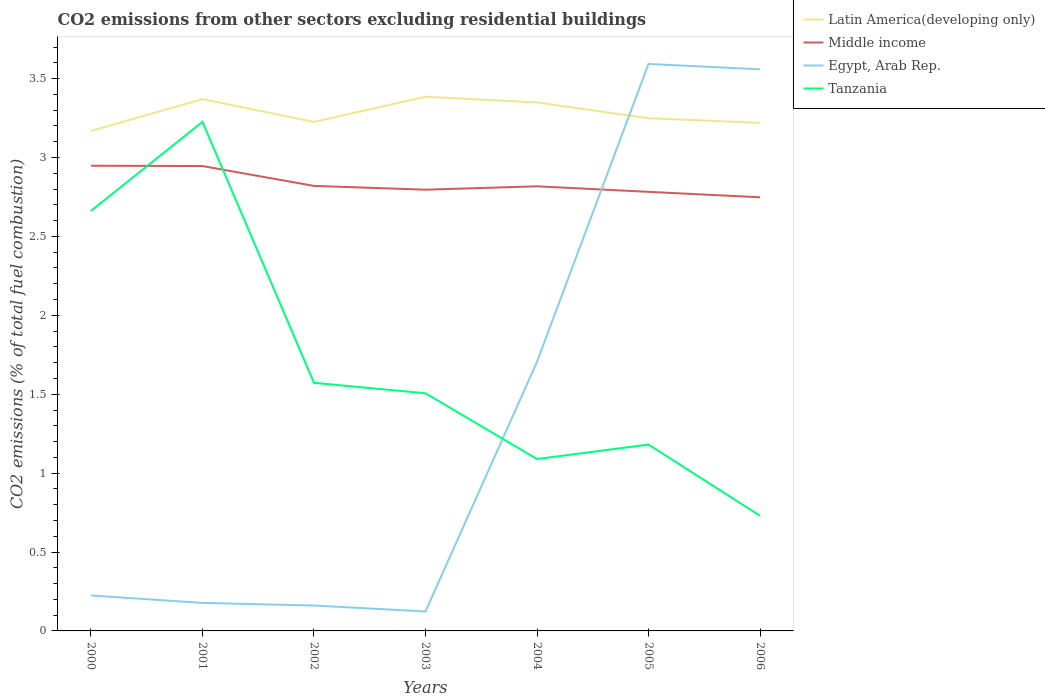How many different coloured lines are there?
Offer a very short reply. 4. Does the line corresponding to Egypt, Arab Rep. intersect with the line corresponding to Latin America(developing only)?
Offer a terse response. Yes. Is the number of lines equal to the number of legend labels?
Offer a very short reply. Yes. Across all years, what is the maximum total CO2 emitted in Egypt, Arab Rep.?
Your response must be concise. 0.12. In which year was the total CO2 emitted in Tanzania maximum?
Ensure brevity in your answer.  2006. What is the total total CO2 emitted in Tanzania in the graph?
Provide a short and direct response. 2.04. What is the difference between the highest and the second highest total CO2 emitted in Egypt, Arab Rep.?
Your answer should be very brief. 3.47. What is the difference between the highest and the lowest total CO2 emitted in Latin America(developing only)?
Keep it short and to the point. 3. Is the total CO2 emitted in Latin America(developing only) strictly greater than the total CO2 emitted in Middle income over the years?
Your answer should be compact. No. How many years are there in the graph?
Offer a very short reply. 7. Does the graph contain any zero values?
Make the answer very short. No. How many legend labels are there?
Provide a succinct answer. 4. What is the title of the graph?
Make the answer very short. CO2 emissions from other sectors excluding residential buildings. What is the label or title of the Y-axis?
Ensure brevity in your answer.  CO2 emissions (% of total fuel combustion). What is the CO2 emissions (% of total fuel combustion) of Latin America(developing only) in 2000?
Offer a very short reply. 3.17. What is the CO2 emissions (% of total fuel combustion) in Middle income in 2000?
Your answer should be very brief. 2.95. What is the CO2 emissions (% of total fuel combustion) in Egypt, Arab Rep. in 2000?
Your answer should be very brief. 0.22. What is the CO2 emissions (% of total fuel combustion) in Tanzania in 2000?
Your response must be concise. 2.66. What is the CO2 emissions (% of total fuel combustion) of Latin America(developing only) in 2001?
Keep it short and to the point. 3.37. What is the CO2 emissions (% of total fuel combustion) of Middle income in 2001?
Your answer should be compact. 2.95. What is the CO2 emissions (% of total fuel combustion) of Egypt, Arab Rep. in 2001?
Your response must be concise. 0.18. What is the CO2 emissions (% of total fuel combustion) in Tanzania in 2001?
Provide a succinct answer. 3.23. What is the CO2 emissions (% of total fuel combustion) of Latin America(developing only) in 2002?
Keep it short and to the point. 3.23. What is the CO2 emissions (% of total fuel combustion) of Middle income in 2002?
Your answer should be very brief. 2.82. What is the CO2 emissions (% of total fuel combustion) in Egypt, Arab Rep. in 2002?
Offer a terse response. 0.16. What is the CO2 emissions (% of total fuel combustion) in Tanzania in 2002?
Your answer should be compact. 1.57. What is the CO2 emissions (% of total fuel combustion) of Latin America(developing only) in 2003?
Your response must be concise. 3.39. What is the CO2 emissions (% of total fuel combustion) in Middle income in 2003?
Make the answer very short. 2.8. What is the CO2 emissions (% of total fuel combustion) of Egypt, Arab Rep. in 2003?
Offer a very short reply. 0.12. What is the CO2 emissions (% of total fuel combustion) of Tanzania in 2003?
Offer a terse response. 1.51. What is the CO2 emissions (% of total fuel combustion) of Latin America(developing only) in 2004?
Your answer should be very brief. 3.35. What is the CO2 emissions (% of total fuel combustion) in Middle income in 2004?
Your response must be concise. 2.82. What is the CO2 emissions (% of total fuel combustion) in Egypt, Arab Rep. in 2004?
Make the answer very short. 1.71. What is the CO2 emissions (% of total fuel combustion) in Tanzania in 2004?
Offer a terse response. 1.09. What is the CO2 emissions (% of total fuel combustion) of Latin America(developing only) in 2005?
Offer a very short reply. 3.25. What is the CO2 emissions (% of total fuel combustion) of Middle income in 2005?
Provide a short and direct response. 2.78. What is the CO2 emissions (% of total fuel combustion) in Egypt, Arab Rep. in 2005?
Provide a succinct answer. 3.59. What is the CO2 emissions (% of total fuel combustion) of Tanzania in 2005?
Your response must be concise. 1.18. What is the CO2 emissions (% of total fuel combustion) of Latin America(developing only) in 2006?
Give a very brief answer. 3.22. What is the CO2 emissions (% of total fuel combustion) in Middle income in 2006?
Your answer should be very brief. 2.75. What is the CO2 emissions (% of total fuel combustion) in Egypt, Arab Rep. in 2006?
Offer a terse response. 3.56. What is the CO2 emissions (% of total fuel combustion) of Tanzania in 2006?
Your answer should be compact. 0.73. Across all years, what is the maximum CO2 emissions (% of total fuel combustion) of Latin America(developing only)?
Provide a succinct answer. 3.39. Across all years, what is the maximum CO2 emissions (% of total fuel combustion) in Middle income?
Offer a terse response. 2.95. Across all years, what is the maximum CO2 emissions (% of total fuel combustion) in Egypt, Arab Rep.?
Keep it short and to the point. 3.59. Across all years, what is the maximum CO2 emissions (% of total fuel combustion) of Tanzania?
Provide a succinct answer. 3.23. Across all years, what is the minimum CO2 emissions (% of total fuel combustion) in Latin America(developing only)?
Provide a succinct answer. 3.17. Across all years, what is the minimum CO2 emissions (% of total fuel combustion) of Middle income?
Your answer should be very brief. 2.75. Across all years, what is the minimum CO2 emissions (% of total fuel combustion) in Egypt, Arab Rep.?
Provide a short and direct response. 0.12. Across all years, what is the minimum CO2 emissions (% of total fuel combustion) in Tanzania?
Provide a short and direct response. 0.73. What is the total CO2 emissions (% of total fuel combustion) in Latin America(developing only) in the graph?
Keep it short and to the point. 22.97. What is the total CO2 emissions (% of total fuel combustion) of Middle income in the graph?
Your answer should be very brief. 19.86. What is the total CO2 emissions (% of total fuel combustion) of Egypt, Arab Rep. in the graph?
Make the answer very short. 9.54. What is the total CO2 emissions (% of total fuel combustion) of Tanzania in the graph?
Keep it short and to the point. 11.97. What is the difference between the CO2 emissions (% of total fuel combustion) in Latin America(developing only) in 2000 and that in 2001?
Your answer should be compact. -0.2. What is the difference between the CO2 emissions (% of total fuel combustion) in Middle income in 2000 and that in 2001?
Offer a terse response. 0. What is the difference between the CO2 emissions (% of total fuel combustion) in Egypt, Arab Rep. in 2000 and that in 2001?
Your answer should be compact. 0.05. What is the difference between the CO2 emissions (% of total fuel combustion) of Tanzania in 2000 and that in 2001?
Provide a succinct answer. -0.56. What is the difference between the CO2 emissions (% of total fuel combustion) of Latin America(developing only) in 2000 and that in 2002?
Provide a short and direct response. -0.06. What is the difference between the CO2 emissions (% of total fuel combustion) in Middle income in 2000 and that in 2002?
Provide a succinct answer. 0.13. What is the difference between the CO2 emissions (% of total fuel combustion) in Egypt, Arab Rep. in 2000 and that in 2002?
Keep it short and to the point. 0.06. What is the difference between the CO2 emissions (% of total fuel combustion) in Tanzania in 2000 and that in 2002?
Your answer should be very brief. 1.09. What is the difference between the CO2 emissions (% of total fuel combustion) in Latin America(developing only) in 2000 and that in 2003?
Provide a short and direct response. -0.22. What is the difference between the CO2 emissions (% of total fuel combustion) of Middle income in 2000 and that in 2003?
Provide a succinct answer. 0.15. What is the difference between the CO2 emissions (% of total fuel combustion) of Egypt, Arab Rep. in 2000 and that in 2003?
Keep it short and to the point. 0.1. What is the difference between the CO2 emissions (% of total fuel combustion) of Tanzania in 2000 and that in 2003?
Your response must be concise. 1.16. What is the difference between the CO2 emissions (% of total fuel combustion) of Latin America(developing only) in 2000 and that in 2004?
Make the answer very short. -0.18. What is the difference between the CO2 emissions (% of total fuel combustion) of Middle income in 2000 and that in 2004?
Offer a terse response. 0.13. What is the difference between the CO2 emissions (% of total fuel combustion) in Egypt, Arab Rep. in 2000 and that in 2004?
Your answer should be compact. -1.48. What is the difference between the CO2 emissions (% of total fuel combustion) of Tanzania in 2000 and that in 2004?
Provide a succinct answer. 1.57. What is the difference between the CO2 emissions (% of total fuel combustion) of Latin America(developing only) in 2000 and that in 2005?
Your response must be concise. -0.08. What is the difference between the CO2 emissions (% of total fuel combustion) of Middle income in 2000 and that in 2005?
Provide a succinct answer. 0.17. What is the difference between the CO2 emissions (% of total fuel combustion) of Egypt, Arab Rep. in 2000 and that in 2005?
Provide a short and direct response. -3.37. What is the difference between the CO2 emissions (% of total fuel combustion) of Tanzania in 2000 and that in 2005?
Offer a terse response. 1.48. What is the difference between the CO2 emissions (% of total fuel combustion) in Latin America(developing only) in 2000 and that in 2006?
Keep it short and to the point. -0.05. What is the difference between the CO2 emissions (% of total fuel combustion) of Egypt, Arab Rep. in 2000 and that in 2006?
Provide a short and direct response. -3.33. What is the difference between the CO2 emissions (% of total fuel combustion) of Tanzania in 2000 and that in 2006?
Provide a short and direct response. 1.93. What is the difference between the CO2 emissions (% of total fuel combustion) of Latin America(developing only) in 2001 and that in 2002?
Your answer should be very brief. 0.14. What is the difference between the CO2 emissions (% of total fuel combustion) in Middle income in 2001 and that in 2002?
Provide a short and direct response. 0.13. What is the difference between the CO2 emissions (% of total fuel combustion) in Egypt, Arab Rep. in 2001 and that in 2002?
Ensure brevity in your answer.  0.02. What is the difference between the CO2 emissions (% of total fuel combustion) in Tanzania in 2001 and that in 2002?
Offer a terse response. 1.65. What is the difference between the CO2 emissions (% of total fuel combustion) of Latin America(developing only) in 2001 and that in 2003?
Provide a succinct answer. -0.02. What is the difference between the CO2 emissions (% of total fuel combustion) of Middle income in 2001 and that in 2003?
Make the answer very short. 0.15. What is the difference between the CO2 emissions (% of total fuel combustion) in Egypt, Arab Rep. in 2001 and that in 2003?
Offer a very short reply. 0.05. What is the difference between the CO2 emissions (% of total fuel combustion) of Tanzania in 2001 and that in 2003?
Ensure brevity in your answer.  1.72. What is the difference between the CO2 emissions (% of total fuel combustion) in Latin America(developing only) in 2001 and that in 2004?
Keep it short and to the point. 0.02. What is the difference between the CO2 emissions (% of total fuel combustion) of Middle income in 2001 and that in 2004?
Provide a succinct answer. 0.13. What is the difference between the CO2 emissions (% of total fuel combustion) in Egypt, Arab Rep. in 2001 and that in 2004?
Provide a short and direct response. -1.53. What is the difference between the CO2 emissions (% of total fuel combustion) of Tanzania in 2001 and that in 2004?
Your answer should be compact. 2.14. What is the difference between the CO2 emissions (% of total fuel combustion) in Latin America(developing only) in 2001 and that in 2005?
Give a very brief answer. 0.12. What is the difference between the CO2 emissions (% of total fuel combustion) of Middle income in 2001 and that in 2005?
Your response must be concise. 0.16. What is the difference between the CO2 emissions (% of total fuel combustion) of Egypt, Arab Rep. in 2001 and that in 2005?
Provide a short and direct response. -3.42. What is the difference between the CO2 emissions (% of total fuel combustion) of Tanzania in 2001 and that in 2005?
Your answer should be compact. 2.04. What is the difference between the CO2 emissions (% of total fuel combustion) of Latin America(developing only) in 2001 and that in 2006?
Provide a succinct answer. 0.15. What is the difference between the CO2 emissions (% of total fuel combustion) in Middle income in 2001 and that in 2006?
Give a very brief answer. 0.2. What is the difference between the CO2 emissions (% of total fuel combustion) in Egypt, Arab Rep. in 2001 and that in 2006?
Ensure brevity in your answer.  -3.38. What is the difference between the CO2 emissions (% of total fuel combustion) in Tanzania in 2001 and that in 2006?
Make the answer very short. 2.5. What is the difference between the CO2 emissions (% of total fuel combustion) in Latin America(developing only) in 2002 and that in 2003?
Your response must be concise. -0.16. What is the difference between the CO2 emissions (% of total fuel combustion) of Middle income in 2002 and that in 2003?
Provide a succinct answer. 0.02. What is the difference between the CO2 emissions (% of total fuel combustion) of Egypt, Arab Rep. in 2002 and that in 2003?
Provide a succinct answer. 0.04. What is the difference between the CO2 emissions (% of total fuel combustion) of Tanzania in 2002 and that in 2003?
Make the answer very short. 0.07. What is the difference between the CO2 emissions (% of total fuel combustion) in Latin America(developing only) in 2002 and that in 2004?
Keep it short and to the point. -0.12. What is the difference between the CO2 emissions (% of total fuel combustion) in Middle income in 2002 and that in 2004?
Provide a succinct answer. 0. What is the difference between the CO2 emissions (% of total fuel combustion) of Egypt, Arab Rep. in 2002 and that in 2004?
Keep it short and to the point. -1.54. What is the difference between the CO2 emissions (% of total fuel combustion) in Tanzania in 2002 and that in 2004?
Provide a short and direct response. 0.48. What is the difference between the CO2 emissions (% of total fuel combustion) in Latin America(developing only) in 2002 and that in 2005?
Your answer should be compact. -0.02. What is the difference between the CO2 emissions (% of total fuel combustion) of Middle income in 2002 and that in 2005?
Offer a very short reply. 0.04. What is the difference between the CO2 emissions (% of total fuel combustion) in Egypt, Arab Rep. in 2002 and that in 2005?
Ensure brevity in your answer.  -3.43. What is the difference between the CO2 emissions (% of total fuel combustion) of Tanzania in 2002 and that in 2005?
Provide a short and direct response. 0.39. What is the difference between the CO2 emissions (% of total fuel combustion) of Latin America(developing only) in 2002 and that in 2006?
Offer a very short reply. 0.01. What is the difference between the CO2 emissions (% of total fuel combustion) in Middle income in 2002 and that in 2006?
Provide a succinct answer. 0.07. What is the difference between the CO2 emissions (% of total fuel combustion) in Egypt, Arab Rep. in 2002 and that in 2006?
Ensure brevity in your answer.  -3.4. What is the difference between the CO2 emissions (% of total fuel combustion) in Tanzania in 2002 and that in 2006?
Provide a short and direct response. 0.84. What is the difference between the CO2 emissions (% of total fuel combustion) in Latin America(developing only) in 2003 and that in 2004?
Give a very brief answer. 0.04. What is the difference between the CO2 emissions (% of total fuel combustion) in Middle income in 2003 and that in 2004?
Make the answer very short. -0.02. What is the difference between the CO2 emissions (% of total fuel combustion) in Egypt, Arab Rep. in 2003 and that in 2004?
Keep it short and to the point. -1.58. What is the difference between the CO2 emissions (% of total fuel combustion) in Tanzania in 2003 and that in 2004?
Give a very brief answer. 0.42. What is the difference between the CO2 emissions (% of total fuel combustion) in Latin America(developing only) in 2003 and that in 2005?
Keep it short and to the point. 0.14. What is the difference between the CO2 emissions (% of total fuel combustion) in Middle income in 2003 and that in 2005?
Provide a short and direct response. 0.01. What is the difference between the CO2 emissions (% of total fuel combustion) of Egypt, Arab Rep. in 2003 and that in 2005?
Give a very brief answer. -3.47. What is the difference between the CO2 emissions (% of total fuel combustion) in Tanzania in 2003 and that in 2005?
Your response must be concise. 0.32. What is the difference between the CO2 emissions (% of total fuel combustion) of Latin America(developing only) in 2003 and that in 2006?
Offer a very short reply. 0.17. What is the difference between the CO2 emissions (% of total fuel combustion) in Middle income in 2003 and that in 2006?
Provide a short and direct response. 0.05. What is the difference between the CO2 emissions (% of total fuel combustion) of Egypt, Arab Rep. in 2003 and that in 2006?
Your answer should be compact. -3.44. What is the difference between the CO2 emissions (% of total fuel combustion) of Tanzania in 2003 and that in 2006?
Ensure brevity in your answer.  0.78. What is the difference between the CO2 emissions (% of total fuel combustion) in Latin America(developing only) in 2004 and that in 2005?
Your answer should be compact. 0.1. What is the difference between the CO2 emissions (% of total fuel combustion) of Middle income in 2004 and that in 2005?
Offer a very short reply. 0.04. What is the difference between the CO2 emissions (% of total fuel combustion) of Egypt, Arab Rep. in 2004 and that in 2005?
Your answer should be compact. -1.89. What is the difference between the CO2 emissions (% of total fuel combustion) in Tanzania in 2004 and that in 2005?
Ensure brevity in your answer.  -0.09. What is the difference between the CO2 emissions (% of total fuel combustion) in Latin America(developing only) in 2004 and that in 2006?
Make the answer very short. 0.13. What is the difference between the CO2 emissions (% of total fuel combustion) of Middle income in 2004 and that in 2006?
Offer a very short reply. 0.07. What is the difference between the CO2 emissions (% of total fuel combustion) of Egypt, Arab Rep. in 2004 and that in 2006?
Your response must be concise. -1.85. What is the difference between the CO2 emissions (% of total fuel combustion) in Tanzania in 2004 and that in 2006?
Your answer should be very brief. 0.36. What is the difference between the CO2 emissions (% of total fuel combustion) of Latin America(developing only) in 2005 and that in 2006?
Offer a very short reply. 0.03. What is the difference between the CO2 emissions (% of total fuel combustion) of Middle income in 2005 and that in 2006?
Provide a succinct answer. 0.03. What is the difference between the CO2 emissions (% of total fuel combustion) of Egypt, Arab Rep. in 2005 and that in 2006?
Ensure brevity in your answer.  0.03. What is the difference between the CO2 emissions (% of total fuel combustion) of Tanzania in 2005 and that in 2006?
Provide a succinct answer. 0.45. What is the difference between the CO2 emissions (% of total fuel combustion) in Latin America(developing only) in 2000 and the CO2 emissions (% of total fuel combustion) in Middle income in 2001?
Your answer should be very brief. 0.22. What is the difference between the CO2 emissions (% of total fuel combustion) of Latin America(developing only) in 2000 and the CO2 emissions (% of total fuel combustion) of Egypt, Arab Rep. in 2001?
Give a very brief answer. 2.99. What is the difference between the CO2 emissions (% of total fuel combustion) in Latin America(developing only) in 2000 and the CO2 emissions (% of total fuel combustion) in Tanzania in 2001?
Your response must be concise. -0.06. What is the difference between the CO2 emissions (% of total fuel combustion) in Middle income in 2000 and the CO2 emissions (% of total fuel combustion) in Egypt, Arab Rep. in 2001?
Provide a short and direct response. 2.77. What is the difference between the CO2 emissions (% of total fuel combustion) of Middle income in 2000 and the CO2 emissions (% of total fuel combustion) of Tanzania in 2001?
Your answer should be very brief. -0.28. What is the difference between the CO2 emissions (% of total fuel combustion) of Egypt, Arab Rep. in 2000 and the CO2 emissions (% of total fuel combustion) of Tanzania in 2001?
Your answer should be compact. -3. What is the difference between the CO2 emissions (% of total fuel combustion) in Latin America(developing only) in 2000 and the CO2 emissions (% of total fuel combustion) in Middle income in 2002?
Ensure brevity in your answer.  0.35. What is the difference between the CO2 emissions (% of total fuel combustion) in Latin America(developing only) in 2000 and the CO2 emissions (% of total fuel combustion) in Egypt, Arab Rep. in 2002?
Offer a terse response. 3.01. What is the difference between the CO2 emissions (% of total fuel combustion) in Latin America(developing only) in 2000 and the CO2 emissions (% of total fuel combustion) in Tanzania in 2002?
Your answer should be very brief. 1.6. What is the difference between the CO2 emissions (% of total fuel combustion) in Middle income in 2000 and the CO2 emissions (% of total fuel combustion) in Egypt, Arab Rep. in 2002?
Your answer should be very brief. 2.79. What is the difference between the CO2 emissions (% of total fuel combustion) in Middle income in 2000 and the CO2 emissions (% of total fuel combustion) in Tanzania in 2002?
Give a very brief answer. 1.38. What is the difference between the CO2 emissions (% of total fuel combustion) of Egypt, Arab Rep. in 2000 and the CO2 emissions (% of total fuel combustion) of Tanzania in 2002?
Provide a short and direct response. -1.35. What is the difference between the CO2 emissions (% of total fuel combustion) of Latin America(developing only) in 2000 and the CO2 emissions (% of total fuel combustion) of Middle income in 2003?
Your answer should be very brief. 0.37. What is the difference between the CO2 emissions (% of total fuel combustion) of Latin America(developing only) in 2000 and the CO2 emissions (% of total fuel combustion) of Egypt, Arab Rep. in 2003?
Make the answer very short. 3.05. What is the difference between the CO2 emissions (% of total fuel combustion) of Latin America(developing only) in 2000 and the CO2 emissions (% of total fuel combustion) of Tanzania in 2003?
Offer a terse response. 1.66. What is the difference between the CO2 emissions (% of total fuel combustion) of Middle income in 2000 and the CO2 emissions (% of total fuel combustion) of Egypt, Arab Rep. in 2003?
Provide a short and direct response. 2.82. What is the difference between the CO2 emissions (% of total fuel combustion) in Middle income in 2000 and the CO2 emissions (% of total fuel combustion) in Tanzania in 2003?
Ensure brevity in your answer.  1.44. What is the difference between the CO2 emissions (% of total fuel combustion) in Egypt, Arab Rep. in 2000 and the CO2 emissions (% of total fuel combustion) in Tanzania in 2003?
Offer a terse response. -1.28. What is the difference between the CO2 emissions (% of total fuel combustion) of Latin America(developing only) in 2000 and the CO2 emissions (% of total fuel combustion) of Middle income in 2004?
Provide a short and direct response. 0.35. What is the difference between the CO2 emissions (% of total fuel combustion) of Latin America(developing only) in 2000 and the CO2 emissions (% of total fuel combustion) of Egypt, Arab Rep. in 2004?
Offer a terse response. 1.46. What is the difference between the CO2 emissions (% of total fuel combustion) in Latin America(developing only) in 2000 and the CO2 emissions (% of total fuel combustion) in Tanzania in 2004?
Offer a very short reply. 2.08. What is the difference between the CO2 emissions (% of total fuel combustion) of Middle income in 2000 and the CO2 emissions (% of total fuel combustion) of Egypt, Arab Rep. in 2004?
Your answer should be very brief. 1.24. What is the difference between the CO2 emissions (% of total fuel combustion) in Middle income in 2000 and the CO2 emissions (% of total fuel combustion) in Tanzania in 2004?
Your answer should be very brief. 1.86. What is the difference between the CO2 emissions (% of total fuel combustion) of Egypt, Arab Rep. in 2000 and the CO2 emissions (% of total fuel combustion) of Tanzania in 2004?
Your answer should be very brief. -0.86. What is the difference between the CO2 emissions (% of total fuel combustion) of Latin America(developing only) in 2000 and the CO2 emissions (% of total fuel combustion) of Middle income in 2005?
Ensure brevity in your answer.  0.39. What is the difference between the CO2 emissions (% of total fuel combustion) in Latin America(developing only) in 2000 and the CO2 emissions (% of total fuel combustion) in Egypt, Arab Rep. in 2005?
Offer a very short reply. -0.42. What is the difference between the CO2 emissions (% of total fuel combustion) in Latin America(developing only) in 2000 and the CO2 emissions (% of total fuel combustion) in Tanzania in 2005?
Your response must be concise. 1.99. What is the difference between the CO2 emissions (% of total fuel combustion) in Middle income in 2000 and the CO2 emissions (% of total fuel combustion) in Egypt, Arab Rep. in 2005?
Your answer should be compact. -0.65. What is the difference between the CO2 emissions (% of total fuel combustion) in Middle income in 2000 and the CO2 emissions (% of total fuel combustion) in Tanzania in 2005?
Your answer should be compact. 1.77. What is the difference between the CO2 emissions (% of total fuel combustion) in Egypt, Arab Rep. in 2000 and the CO2 emissions (% of total fuel combustion) in Tanzania in 2005?
Your answer should be very brief. -0.96. What is the difference between the CO2 emissions (% of total fuel combustion) of Latin America(developing only) in 2000 and the CO2 emissions (% of total fuel combustion) of Middle income in 2006?
Provide a succinct answer. 0.42. What is the difference between the CO2 emissions (% of total fuel combustion) in Latin America(developing only) in 2000 and the CO2 emissions (% of total fuel combustion) in Egypt, Arab Rep. in 2006?
Ensure brevity in your answer.  -0.39. What is the difference between the CO2 emissions (% of total fuel combustion) of Latin America(developing only) in 2000 and the CO2 emissions (% of total fuel combustion) of Tanzania in 2006?
Provide a succinct answer. 2.44. What is the difference between the CO2 emissions (% of total fuel combustion) in Middle income in 2000 and the CO2 emissions (% of total fuel combustion) in Egypt, Arab Rep. in 2006?
Provide a succinct answer. -0.61. What is the difference between the CO2 emissions (% of total fuel combustion) of Middle income in 2000 and the CO2 emissions (% of total fuel combustion) of Tanzania in 2006?
Your answer should be very brief. 2.22. What is the difference between the CO2 emissions (% of total fuel combustion) of Egypt, Arab Rep. in 2000 and the CO2 emissions (% of total fuel combustion) of Tanzania in 2006?
Your answer should be compact. -0.51. What is the difference between the CO2 emissions (% of total fuel combustion) of Latin America(developing only) in 2001 and the CO2 emissions (% of total fuel combustion) of Middle income in 2002?
Keep it short and to the point. 0.55. What is the difference between the CO2 emissions (% of total fuel combustion) of Latin America(developing only) in 2001 and the CO2 emissions (% of total fuel combustion) of Egypt, Arab Rep. in 2002?
Your response must be concise. 3.21. What is the difference between the CO2 emissions (% of total fuel combustion) in Latin America(developing only) in 2001 and the CO2 emissions (% of total fuel combustion) in Tanzania in 2002?
Ensure brevity in your answer.  1.8. What is the difference between the CO2 emissions (% of total fuel combustion) of Middle income in 2001 and the CO2 emissions (% of total fuel combustion) of Egypt, Arab Rep. in 2002?
Ensure brevity in your answer.  2.79. What is the difference between the CO2 emissions (% of total fuel combustion) of Middle income in 2001 and the CO2 emissions (% of total fuel combustion) of Tanzania in 2002?
Offer a terse response. 1.37. What is the difference between the CO2 emissions (% of total fuel combustion) of Egypt, Arab Rep. in 2001 and the CO2 emissions (% of total fuel combustion) of Tanzania in 2002?
Provide a succinct answer. -1.39. What is the difference between the CO2 emissions (% of total fuel combustion) of Latin America(developing only) in 2001 and the CO2 emissions (% of total fuel combustion) of Middle income in 2003?
Provide a short and direct response. 0.57. What is the difference between the CO2 emissions (% of total fuel combustion) in Latin America(developing only) in 2001 and the CO2 emissions (% of total fuel combustion) in Egypt, Arab Rep. in 2003?
Make the answer very short. 3.25. What is the difference between the CO2 emissions (% of total fuel combustion) of Latin America(developing only) in 2001 and the CO2 emissions (% of total fuel combustion) of Tanzania in 2003?
Provide a short and direct response. 1.86. What is the difference between the CO2 emissions (% of total fuel combustion) in Middle income in 2001 and the CO2 emissions (% of total fuel combustion) in Egypt, Arab Rep. in 2003?
Offer a terse response. 2.82. What is the difference between the CO2 emissions (% of total fuel combustion) in Middle income in 2001 and the CO2 emissions (% of total fuel combustion) in Tanzania in 2003?
Offer a terse response. 1.44. What is the difference between the CO2 emissions (% of total fuel combustion) in Egypt, Arab Rep. in 2001 and the CO2 emissions (% of total fuel combustion) in Tanzania in 2003?
Give a very brief answer. -1.33. What is the difference between the CO2 emissions (% of total fuel combustion) of Latin America(developing only) in 2001 and the CO2 emissions (% of total fuel combustion) of Middle income in 2004?
Provide a succinct answer. 0.55. What is the difference between the CO2 emissions (% of total fuel combustion) of Latin America(developing only) in 2001 and the CO2 emissions (% of total fuel combustion) of Egypt, Arab Rep. in 2004?
Your answer should be very brief. 1.66. What is the difference between the CO2 emissions (% of total fuel combustion) of Latin America(developing only) in 2001 and the CO2 emissions (% of total fuel combustion) of Tanzania in 2004?
Keep it short and to the point. 2.28. What is the difference between the CO2 emissions (% of total fuel combustion) in Middle income in 2001 and the CO2 emissions (% of total fuel combustion) in Egypt, Arab Rep. in 2004?
Make the answer very short. 1.24. What is the difference between the CO2 emissions (% of total fuel combustion) in Middle income in 2001 and the CO2 emissions (% of total fuel combustion) in Tanzania in 2004?
Your answer should be compact. 1.86. What is the difference between the CO2 emissions (% of total fuel combustion) of Egypt, Arab Rep. in 2001 and the CO2 emissions (% of total fuel combustion) of Tanzania in 2004?
Offer a very short reply. -0.91. What is the difference between the CO2 emissions (% of total fuel combustion) in Latin America(developing only) in 2001 and the CO2 emissions (% of total fuel combustion) in Middle income in 2005?
Offer a terse response. 0.59. What is the difference between the CO2 emissions (% of total fuel combustion) in Latin America(developing only) in 2001 and the CO2 emissions (% of total fuel combustion) in Egypt, Arab Rep. in 2005?
Offer a very short reply. -0.22. What is the difference between the CO2 emissions (% of total fuel combustion) of Latin America(developing only) in 2001 and the CO2 emissions (% of total fuel combustion) of Tanzania in 2005?
Offer a terse response. 2.19. What is the difference between the CO2 emissions (% of total fuel combustion) in Middle income in 2001 and the CO2 emissions (% of total fuel combustion) in Egypt, Arab Rep. in 2005?
Offer a terse response. -0.65. What is the difference between the CO2 emissions (% of total fuel combustion) of Middle income in 2001 and the CO2 emissions (% of total fuel combustion) of Tanzania in 2005?
Ensure brevity in your answer.  1.76. What is the difference between the CO2 emissions (% of total fuel combustion) of Egypt, Arab Rep. in 2001 and the CO2 emissions (% of total fuel combustion) of Tanzania in 2005?
Provide a succinct answer. -1. What is the difference between the CO2 emissions (% of total fuel combustion) of Latin America(developing only) in 2001 and the CO2 emissions (% of total fuel combustion) of Middle income in 2006?
Make the answer very short. 0.62. What is the difference between the CO2 emissions (% of total fuel combustion) in Latin America(developing only) in 2001 and the CO2 emissions (% of total fuel combustion) in Egypt, Arab Rep. in 2006?
Offer a terse response. -0.19. What is the difference between the CO2 emissions (% of total fuel combustion) of Latin America(developing only) in 2001 and the CO2 emissions (% of total fuel combustion) of Tanzania in 2006?
Your answer should be compact. 2.64. What is the difference between the CO2 emissions (% of total fuel combustion) of Middle income in 2001 and the CO2 emissions (% of total fuel combustion) of Egypt, Arab Rep. in 2006?
Keep it short and to the point. -0.61. What is the difference between the CO2 emissions (% of total fuel combustion) of Middle income in 2001 and the CO2 emissions (% of total fuel combustion) of Tanzania in 2006?
Offer a terse response. 2.22. What is the difference between the CO2 emissions (% of total fuel combustion) of Egypt, Arab Rep. in 2001 and the CO2 emissions (% of total fuel combustion) of Tanzania in 2006?
Provide a succinct answer. -0.55. What is the difference between the CO2 emissions (% of total fuel combustion) of Latin America(developing only) in 2002 and the CO2 emissions (% of total fuel combustion) of Middle income in 2003?
Offer a very short reply. 0.43. What is the difference between the CO2 emissions (% of total fuel combustion) in Latin America(developing only) in 2002 and the CO2 emissions (% of total fuel combustion) in Egypt, Arab Rep. in 2003?
Offer a terse response. 3.1. What is the difference between the CO2 emissions (% of total fuel combustion) of Latin America(developing only) in 2002 and the CO2 emissions (% of total fuel combustion) of Tanzania in 2003?
Ensure brevity in your answer.  1.72. What is the difference between the CO2 emissions (% of total fuel combustion) of Middle income in 2002 and the CO2 emissions (% of total fuel combustion) of Egypt, Arab Rep. in 2003?
Keep it short and to the point. 2.7. What is the difference between the CO2 emissions (% of total fuel combustion) of Middle income in 2002 and the CO2 emissions (% of total fuel combustion) of Tanzania in 2003?
Ensure brevity in your answer.  1.31. What is the difference between the CO2 emissions (% of total fuel combustion) in Egypt, Arab Rep. in 2002 and the CO2 emissions (% of total fuel combustion) in Tanzania in 2003?
Provide a succinct answer. -1.35. What is the difference between the CO2 emissions (% of total fuel combustion) of Latin America(developing only) in 2002 and the CO2 emissions (% of total fuel combustion) of Middle income in 2004?
Make the answer very short. 0.41. What is the difference between the CO2 emissions (% of total fuel combustion) in Latin America(developing only) in 2002 and the CO2 emissions (% of total fuel combustion) in Egypt, Arab Rep. in 2004?
Make the answer very short. 1.52. What is the difference between the CO2 emissions (% of total fuel combustion) in Latin America(developing only) in 2002 and the CO2 emissions (% of total fuel combustion) in Tanzania in 2004?
Offer a very short reply. 2.14. What is the difference between the CO2 emissions (% of total fuel combustion) in Middle income in 2002 and the CO2 emissions (% of total fuel combustion) in Egypt, Arab Rep. in 2004?
Ensure brevity in your answer.  1.11. What is the difference between the CO2 emissions (% of total fuel combustion) of Middle income in 2002 and the CO2 emissions (% of total fuel combustion) of Tanzania in 2004?
Give a very brief answer. 1.73. What is the difference between the CO2 emissions (% of total fuel combustion) of Egypt, Arab Rep. in 2002 and the CO2 emissions (% of total fuel combustion) of Tanzania in 2004?
Give a very brief answer. -0.93. What is the difference between the CO2 emissions (% of total fuel combustion) in Latin America(developing only) in 2002 and the CO2 emissions (% of total fuel combustion) in Middle income in 2005?
Offer a terse response. 0.44. What is the difference between the CO2 emissions (% of total fuel combustion) of Latin America(developing only) in 2002 and the CO2 emissions (% of total fuel combustion) of Egypt, Arab Rep. in 2005?
Your answer should be very brief. -0.37. What is the difference between the CO2 emissions (% of total fuel combustion) in Latin America(developing only) in 2002 and the CO2 emissions (% of total fuel combustion) in Tanzania in 2005?
Your response must be concise. 2.04. What is the difference between the CO2 emissions (% of total fuel combustion) of Middle income in 2002 and the CO2 emissions (% of total fuel combustion) of Egypt, Arab Rep. in 2005?
Make the answer very short. -0.77. What is the difference between the CO2 emissions (% of total fuel combustion) of Middle income in 2002 and the CO2 emissions (% of total fuel combustion) of Tanzania in 2005?
Offer a very short reply. 1.64. What is the difference between the CO2 emissions (% of total fuel combustion) in Egypt, Arab Rep. in 2002 and the CO2 emissions (% of total fuel combustion) in Tanzania in 2005?
Provide a succinct answer. -1.02. What is the difference between the CO2 emissions (% of total fuel combustion) of Latin America(developing only) in 2002 and the CO2 emissions (% of total fuel combustion) of Middle income in 2006?
Give a very brief answer. 0.48. What is the difference between the CO2 emissions (% of total fuel combustion) of Latin America(developing only) in 2002 and the CO2 emissions (% of total fuel combustion) of Egypt, Arab Rep. in 2006?
Your answer should be very brief. -0.33. What is the difference between the CO2 emissions (% of total fuel combustion) of Latin America(developing only) in 2002 and the CO2 emissions (% of total fuel combustion) of Tanzania in 2006?
Provide a short and direct response. 2.5. What is the difference between the CO2 emissions (% of total fuel combustion) of Middle income in 2002 and the CO2 emissions (% of total fuel combustion) of Egypt, Arab Rep. in 2006?
Your answer should be very brief. -0.74. What is the difference between the CO2 emissions (% of total fuel combustion) of Middle income in 2002 and the CO2 emissions (% of total fuel combustion) of Tanzania in 2006?
Your answer should be compact. 2.09. What is the difference between the CO2 emissions (% of total fuel combustion) of Egypt, Arab Rep. in 2002 and the CO2 emissions (% of total fuel combustion) of Tanzania in 2006?
Keep it short and to the point. -0.57. What is the difference between the CO2 emissions (% of total fuel combustion) of Latin America(developing only) in 2003 and the CO2 emissions (% of total fuel combustion) of Middle income in 2004?
Your answer should be compact. 0.57. What is the difference between the CO2 emissions (% of total fuel combustion) of Latin America(developing only) in 2003 and the CO2 emissions (% of total fuel combustion) of Egypt, Arab Rep. in 2004?
Your answer should be very brief. 1.68. What is the difference between the CO2 emissions (% of total fuel combustion) in Latin America(developing only) in 2003 and the CO2 emissions (% of total fuel combustion) in Tanzania in 2004?
Offer a terse response. 2.3. What is the difference between the CO2 emissions (% of total fuel combustion) of Middle income in 2003 and the CO2 emissions (% of total fuel combustion) of Tanzania in 2004?
Your answer should be very brief. 1.71. What is the difference between the CO2 emissions (% of total fuel combustion) of Egypt, Arab Rep. in 2003 and the CO2 emissions (% of total fuel combustion) of Tanzania in 2004?
Your response must be concise. -0.97. What is the difference between the CO2 emissions (% of total fuel combustion) of Latin America(developing only) in 2003 and the CO2 emissions (% of total fuel combustion) of Middle income in 2005?
Provide a succinct answer. 0.6. What is the difference between the CO2 emissions (% of total fuel combustion) of Latin America(developing only) in 2003 and the CO2 emissions (% of total fuel combustion) of Egypt, Arab Rep. in 2005?
Offer a terse response. -0.21. What is the difference between the CO2 emissions (% of total fuel combustion) in Latin America(developing only) in 2003 and the CO2 emissions (% of total fuel combustion) in Tanzania in 2005?
Make the answer very short. 2.2. What is the difference between the CO2 emissions (% of total fuel combustion) of Middle income in 2003 and the CO2 emissions (% of total fuel combustion) of Egypt, Arab Rep. in 2005?
Provide a short and direct response. -0.8. What is the difference between the CO2 emissions (% of total fuel combustion) in Middle income in 2003 and the CO2 emissions (% of total fuel combustion) in Tanzania in 2005?
Your answer should be very brief. 1.62. What is the difference between the CO2 emissions (% of total fuel combustion) of Egypt, Arab Rep. in 2003 and the CO2 emissions (% of total fuel combustion) of Tanzania in 2005?
Your answer should be compact. -1.06. What is the difference between the CO2 emissions (% of total fuel combustion) of Latin America(developing only) in 2003 and the CO2 emissions (% of total fuel combustion) of Middle income in 2006?
Your answer should be very brief. 0.64. What is the difference between the CO2 emissions (% of total fuel combustion) of Latin America(developing only) in 2003 and the CO2 emissions (% of total fuel combustion) of Egypt, Arab Rep. in 2006?
Ensure brevity in your answer.  -0.17. What is the difference between the CO2 emissions (% of total fuel combustion) in Latin America(developing only) in 2003 and the CO2 emissions (% of total fuel combustion) in Tanzania in 2006?
Offer a terse response. 2.66. What is the difference between the CO2 emissions (% of total fuel combustion) of Middle income in 2003 and the CO2 emissions (% of total fuel combustion) of Egypt, Arab Rep. in 2006?
Give a very brief answer. -0.76. What is the difference between the CO2 emissions (% of total fuel combustion) of Middle income in 2003 and the CO2 emissions (% of total fuel combustion) of Tanzania in 2006?
Ensure brevity in your answer.  2.07. What is the difference between the CO2 emissions (% of total fuel combustion) in Egypt, Arab Rep. in 2003 and the CO2 emissions (% of total fuel combustion) in Tanzania in 2006?
Provide a short and direct response. -0.61. What is the difference between the CO2 emissions (% of total fuel combustion) of Latin America(developing only) in 2004 and the CO2 emissions (% of total fuel combustion) of Middle income in 2005?
Your response must be concise. 0.57. What is the difference between the CO2 emissions (% of total fuel combustion) in Latin America(developing only) in 2004 and the CO2 emissions (% of total fuel combustion) in Egypt, Arab Rep. in 2005?
Your answer should be very brief. -0.24. What is the difference between the CO2 emissions (% of total fuel combustion) of Latin America(developing only) in 2004 and the CO2 emissions (% of total fuel combustion) of Tanzania in 2005?
Offer a very short reply. 2.17. What is the difference between the CO2 emissions (% of total fuel combustion) of Middle income in 2004 and the CO2 emissions (% of total fuel combustion) of Egypt, Arab Rep. in 2005?
Your answer should be very brief. -0.78. What is the difference between the CO2 emissions (% of total fuel combustion) in Middle income in 2004 and the CO2 emissions (% of total fuel combustion) in Tanzania in 2005?
Keep it short and to the point. 1.64. What is the difference between the CO2 emissions (% of total fuel combustion) in Egypt, Arab Rep. in 2004 and the CO2 emissions (% of total fuel combustion) in Tanzania in 2005?
Your answer should be very brief. 0.52. What is the difference between the CO2 emissions (% of total fuel combustion) in Latin America(developing only) in 2004 and the CO2 emissions (% of total fuel combustion) in Middle income in 2006?
Make the answer very short. 0.6. What is the difference between the CO2 emissions (% of total fuel combustion) in Latin America(developing only) in 2004 and the CO2 emissions (% of total fuel combustion) in Egypt, Arab Rep. in 2006?
Keep it short and to the point. -0.21. What is the difference between the CO2 emissions (% of total fuel combustion) in Latin America(developing only) in 2004 and the CO2 emissions (% of total fuel combustion) in Tanzania in 2006?
Offer a terse response. 2.62. What is the difference between the CO2 emissions (% of total fuel combustion) in Middle income in 2004 and the CO2 emissions (% of total fuel combustion) in Egypt, Arab Rep. in 2006?
Give a very brief answer. -0.74. What is the difference between the CO2 emissions (% of total fuel combustion) in Middle income in 2004 and the CO2 emissions (% of total fuel combustion) in Tanzania in 2006?
Ensure brevity in your answer.  2.09. What is the difference between the CO2 emissions (% of total fuel combustion) of Egypt, Arab Rep. in 2004 and the CO2 emissions (% of total fuel combustion) of Tanzania in 2006?
Offer a terse response. 0.98. What is the difference between the CO2 emissions (% of total fuel combustion) in Latin America(developing only) in 2005 and the CO2 emissions (% of total fuel combustion) in Middle income in 2006?
Your answer should be very brief. 0.5. What is the difference between the CO2 emissions (% of total fuel combustion) in Latin America(developing only) in 2005 and the CO2 emissions (% of total fuel combustion) in Egypt, Arab Rep. in 2006?
Ensure brevity in your answer.  -0.31. What is the difference between the CO2 emissions (% of total fuel combustion) of Latin America(developing only) in 2005 and the CO2 emissions (% of total fuel combustion) of Tanzania in 2006?
Provide a succinct answer. 2.52. What is the difference between the CO2 emissions (% of total fuel combustion) in Middle income in 2005 and the CO2 emissions (% of total fuel combustion) in Egypt, Arab Rep. in 2006?
Ensure brevity in your answer.  -0.78. What is the difference between the CO2 emissions (% of total fuel combustion) of Middle income in 2005 and the CO2 emissions (% of total fuel combustion) of Tanzania in 2006?
Offer a very short reply. 2.05. What is the difference between the CO2 emissions (% of total fuel combustion) of Egypt, Arab Rep. in 2005 and the CO2 emissions (% of total fuel combustion) of Tanzania in 2006?
Provide a succinct answer. 2.86. What is the average CO2 emissions (% of total fuel combustion) in Latin America(developing only) per year?
Your answer should be compact. 3.28. What is the average CO2 emissions (% of total fuel combustion) in Middle income per year?
Your answer should be very brief. 2.84. What is the average CO2 emissions (% of total fuel combustion) in Egypt, Arab Rep. per year?
Make the answer very short. 1.36. What is the average CO2 emissions (% of total fuel combustion) in Tanzania per year?
Keep it short and to the point. 1.71. In the year 2000, what is the difference between the CO2 emissions (% of total fuel combustion) in Latin America(developing only) and CO2 emissions (% of total fuel combustion) in Middle income?
Your answer should be very brief. 0.22. In the year 2000, what is the difference between the CO2 emissions (% of total fuel combustion) in Latin America(developing only) and CO2 emissions (% of total fuel combustion) in Egypt, Arab Rep.?
Your answer should be compact. 2.94. In the year 2000, what is the difference between the CO2 emissions (% of total fuel combustion) of Latin America(developing only) and CO2 emissions (% of total fuel combustion) of Tanzania?
Provide a succinct answer. 0.51. In the year 2000, what is the difference between the CO2 emissions (% of total fuel combustion) of Middle income and CO2 emissions (% of total fuel combustion) of Egypt, Arab Rep.?
Give a very brief answer. 2.72. In the year 2000, what is the difference between the CO2 emissions (% of total fuel combustion) in Middle income and CO2 emissions (% of total fuel combustion) in Tanzania?
Make the answer very short. 0.29. In the year 2000, what is the difference between the CO2 emissions (% of total fuel combustion) of Egypt, Arab Rep. and CO2 emissions (% of total fuel combustion) of Tanzania?
Offer a terse response. -2.44. In the year 2001, what is the difference between the CO2 emissions (% of total fuel combustion) of Latin America(developing only) and CO2 emissions (% of total fuel combustion) of Middle income?
Provide a short and direct response. 0.42. In the year 2001, what is the difference between the CO2 emissions (% of total fuel combustion) in Latin America(developing only) and CO2 emissions (% of total fuel combustion) in Egypt, Arab Rep.?
Your response must be concise. 3.19. In the year 2001, what is the difference between the CO2 emissions (% of total fuel combustion) in Latin America(developing only) and CO2 emissions (% of total fuel combustion) in Tanzania?
Provide a succinct answer. 0.14. In the year 2001, what is the difference between the CO2 emissions (% of total fuel combustion) of Middle income and CO2 emissions (% of total fuel combustion) of Egypt, Arab Rep.?
Your response must be concise. 2.77. In the year 2001, what is the difference between the CO2 emissions (% of total fuel combustion) in Middle income and CO2 emissions (% of total fuel combustion) in Tanzania?
Offer a very short reply. -0.28. In the year 2001, what is the difference between the CO2 emissions (% of total fuel combustion) in Egypt, Arab Rep. and CO2 emissions (% of total fuel combustion) in Tanzania?
Your answer should be very brief. -3.05. In the year 2002, what is the difference between the CO2 emissions (% of total fuel combustion) of Latin America(developing only) and CO2 emissions (% of total fuel combustion) of Middle income?
Your answer should be very brief. 0.41. In the year 2002, what is the difference between the CO2 emissions (% of total fuel combustion) of Latin America(developing only) and CO2 emissions (% of total fuel combustion) of Egypt, Arab Rep.?
Your answer should be very brief. 3.06. In the year 2002, what is the difference between the CO2 emissions (% of total fuel combustion) of Latin America(developing only) and CO2 emissions (% of total fuel combustion) of Tanzania?
Make the answer very short. 1.65. In the year 2002, what is the difference between the CO2 emissions (% of total fuel combustion) in Middle income and CO2 emissions (% of total fuel combustion) in Egypt, Arab Rep.?
Your answer should be compact. 2.66. In the year 2002, what is the difference between the CO2 emissions (% of total fuel combustion) of Middle income and CO2 emissions (% of total fuel combustion) of Tanzania?
Offer a very short reply. 1.25. In the year 2002, what is the difference between the CO2 emissions (% of total fuel combustion) of Egypt, Arab Rep. and CO2 emissions (% of total fuel combustion) of Tanzania?
Provide a succinct answer. -1.41. In the year 2003, what is the difference between the CO2 emissions (% of total fuel combustion) of Latin America(developing only) and CO2 emissions (% of total fuel combustion) of Middle income?
Your answer should be very brief. 0.59. In the year 2003, what is the difference between the CO2 emissions (% of total fuel combustion) of Latin America(developing only) and CO2 emissions (% of total fuel combustion) of Egypt, Arab Rep.?
Keep it short and to the point. 3.26. In the year 2003, what is the difference between the CO2 emissions (% of total fuel combustion) in Latin America(developing only) and CO2 emissions (% of total fuel combustion) in Tanzania?
Offer a very short reply. 1.88. In the year 2003, what is the difference between the CO2 emissions (% of total fuel combustion) of Middle income and CO2 emissions (% of total fuel combustion) of Egypt, Arab Rep.?
Make the answer very short. 2.67. In the year 2003, what is the difference between the CO2 emissions (% of total fuel combustion) of Middle income and CO2 emissions (% of total fuel combustion) of Tanzania?
Ensure brevity in your answer.  1.29. In the year 2003, what is the difference between the CO2 emissions (% of total fuel combustion) of Egypt, Arab Rep. and CO2 emissions (% of total fuel combustion) of Tanzania?
Your answer should be very brief. -1.38. In the year 2004, what is the difference between the CO2 emissions (% of total fuel combustion) in Latin America(developing only) and CO2 emissions (% of total fuel combustion) in Middle income?
Give a very brief answer. 0.53. In the year 2004, what is the difference between the CO2 emissions (% of total fuel combustion) of Latin America(developing only) and CO2 emissions (% of total fuel combustion) of Egypt, Arab Rep.?
Offer a very short reply. 1.64. In the year 2004, what is the difference between the CO2 emissions (% of total fuel combustion) in Latin America(developing only) and CO2 emissions (% of total fuel combustion) in Tanzania?
Make the answer very short. 2.26. In the year 2004, what is the difference between the CO2 emissions (% of total fuel combustion) in Middle income and CO2 emissions (% of total fuel combustion) in Egypt, Arab Rep.?
Your response must be concise. 1.11. In the year 2004, what is the difference between the CO2 emissions (% of total fuel combustion) of Middle income and CO2 emissions (% of total fuel combustion) of Tanzania?
Make the answer very short. 1.73. In the year 2004, what is the difference between the CO2 emissions (% of total fuel combustion) of Egypt, Arab Rep. and CO2 emissions (% of total fuel combustion) of Tanzania?
Provide a succinct answer. 0.62. In the year 2005, what is the difference between the CO2 emissions (% of total fuel combustion) of Latin America(developing only) and CO2 emissions (% of total fuel combustion) of Middle income?
Your answer should be very brief. 0.47. In the year 2005, what is the difference between the CO2 emissions (% of total fuel combustion) of Latin America(developing only) and CO2 emissions (% of total fuel combustion) of Egypt, Arab Rep.?
Give a very brief answer. -0.34. In the year 2005, what is the difference between the CO2 emissions (% of total fuel combustion) of Latin America(developing only) and CO2 emissions (% of total fuel combustion) of Tanzania?
Your answer should be very brief. 2.07. In the year 2005, what is the difference between the CO2 emissions (% of total fuel combustion) in Middle income and CO2 emissions (% of total fuel combustion) in Egypt, Arab Rep.?
Your answer should be very brief. -0.81. In the year 2005, what is the difference between the CO2 emissions (% of total fuel combustion) of Middle income and CO2 emissions (% of total fuel combustion) of Tanzania?
Provide a short and direct response. 1.6. In the year 2005, what is the difference between the CO2 emissions (% of total fuel combustion) of Egypt, Arab Rep. and CO2 emissions (% of total fuel combustion) of Tanzania?
Your response must be concise. 2.41. In the year 2006, what is the difference between the CO2 emissions (% of total fuel combustion) in Latin America(developing only) and CO2 emissions (% of total fuel combustion) in Middle income?
Give a very brief answer. 0.47. In the year 2006, what is the difference between the CO2 emissions (% of total fuel combustion) in Latin America(developing only) and CO2 emissions (% of total fuel combustion) in Egypt, Arab Rep.?
Offer a terse response. -0.34. In the year 2006, what is the difference between the CO2 emissions (% of total fuel combustion) in Latin America(developing only) and CO2 emissions (% of total fuel combustion) in Tanzania?
Provide a short and direct response. 2.49. In the year 2006, what is the difference between the CO2 emissions (% of total fuel combustion) of Middle income and CO2 emissions (% of total fuel combustion) of Egypt, Arab Rep.?
Your response must be concise. -0.81. In the year 2006, what is the difference between the CO2 emissions (% of total fuel combustion) in Middle income and CO2 emissions (% of total fuel combustion) in Tanzania?
Offer a very short reply. 2.02. In the year 2006, what is the difference between the CO2 emissions (% of total fuel combustion) of Egypt, Arab Rep. and CO2 emissions (% of total fuel combustion) of Tanzania?
Your answer should be very brief. 2.83. What is the ratio of the CO2 emissions (% of total fuel combustion) of Latin America(developing only) in 2000 to that in 2001?
Ensure brevity in your answer.  0.94. What is the ratio of the CO2 emissions (% of total fuel combustion) in Egypt, Arab Rep. in 2000 to that in 2001?
Provide a succinct answer. 1.26. What is the ratio of the CO2 emissions (% of total fuel combustion) of Tanzania in 2000 to that in 2001?
Give a very brief answer. 0.83. What is the ratio of the CO2 emissions (% of total fuel combustion) in Latin America(developing only) in 2000 to that in 2002?
Offer a terse response. 0.98. What is the ratio of the CO2 emissions (% of total fuel combustion) in Middle income in 2000 to that in 2002?
Give a very brief answer. 1.05. What is the ratio of the CO2 emissions (% of total fuel combustion) in Egypt, Arab Rep. in 2000 to that in 2002?
Make the answer very short. 1.4. What is the ratio of the CO2 emissions (% of total fuel combustion) in Tanzania in 2000 to that in 2002?
Ensure brevity in your answer.  1.69. What is the ratio of the CO2 emissions (% of total fuel combustion) of Latin America(developing only) in 2000 to that in 2003?
Provide a short and direct response. 0.94. What is the ratio of the CO2 emissions (% of total fuel combustion) in Middle income in 2000 to that in 2003?
Your response must be concise. 1.05. What is the ratio of the CO2 emissions (% of total fuel combustion) in Egypt, Arab Rep. in 2000 to that in 2003?
Give a very brief answer. 1.82. What is the ratio of the CO2 emissions (% of total fuel combustion) of Tanzania in 2000 to that in 2003?
Offer a very short reply. 1.77. What is the ratio of the CO2 emissions (% of total fuel combustion) in Latin America(developing only) in 2000 to that in 2004?
Your answer should be very brief. 0.95. What is the ratio of the CO2 emissions (% of total fuel combustion) in Middle income in 2000 to that in 2004?
Your response must be concise. 1.05. What is the ratio of the CO2 emissions (% of total fuel combustion) in Egypt, Arab Rep. in 2000 to that in 2004?
Give a very brief answer. 0.13. What is the ratio of the CO2 emissions (% of total fuel combustion) in Tanzania in 2000 to that in 2004?
Your answer should be compact. 2.44. What is the ratio of the CO2 emissions (% of total fuel combustion) in Latin America(developing only) in 2000 to that in 2005?
Offer a terse response. 0.98. What is the ratio of the CO2 emissions (% of total fuel combustion) in Middle income in 2000 to that in 2005?
Your response must be concise. 1.06. What is the ratio of the CO2 emissions (% of total fuel combustion) in Egypt, Arab Rep. in 2000 to that in 2005?
Offer a terse response. 0.06. What is the ratio of the CO2 emissions (% of total fuel combustion) in Tanzania in 2000 to that in 2005?
Keep it short and to the point. 2.25. What is the ratio of the CO2 emissions (% of total fuel combustion) of Latin America(developing only) in 2000 to that in 2006?
Keep it short and to the point. 0.98. What is the ratio of the CO2 emissions (% of total fuel combustion) in Middle income in 2000 to that in 2006?
Your answer should be compact. 1.07. What is the ratio of the CO2 emissions (% of total fuel combustion) of Egypt, Arab Rep. in 2000 to that in 2006?
Provide a succinct answer. 0.06. What is the ratio of the CO2 emissions (% of total fuel combustion) of Tanzania in 2000 to that in 2006?
Offer a very short reply. 3.65. What is the ratio of the CO2 emissions (% of total fuel combustion) in Latin America(developing only) in 2001 to that in 2002?
Offer a very short reply. 1.04. What is the ratio of the CO2 emissions (% of total fuel combustion) of Middle income in 2001 to that in 2002?
Give a very brief answer. 1.04. What is the ratio of the CO2 emissions (% of total fuel combustion) in Egypt, Arab Rep. in 2001 to that in 2002?
Provide a short and direct response. 1.1. What is the ratio of the CO2 emissions (% of total fuel combustion) of Tanzania in 2001 to that in 2002?
Offer a very short reply. 2.05. What is the ratio of the CO2 emissions (% of total fuel combustion) of Latin America(developing only) in 2001 to that in 2003?
Your answer should be very brief. 1. What is the ratio of the CO2 emissions (% of total fuel combustion) of Middle income in 2001 to that in 2003?
Your answer should be compact. 1.05. What is the ratio of the CO2 emissions (% of total fuel combustion) of Egypt, Arab Rep. in 2001 to that in 2003?
Your answer should be compact. 1.44. What is the ratio of the CO2 emissions (% of total fuel combustion) in Tanzania in 2001 to that in 2003?
Provide a succinct answer. 2.14. What is the ratio of the CO2 emissions (% of total fuel combustion) of Latin America(developing only) in 2001 to that in 2004?
Your answer should be very brief. 1.01. What is the ratio of the CO2 emissions (% of total fuel combustion) in Middle income in 2001 to that in 2004?
Make the answer very short. 1.05. What is the ratio of the CO2 emissions (% of total fuel combustion) in Egypt, Arab Rep. in 2001 to that in 2004?
Offer a very short reply. 0.1. What is the ratio of the CO2 emissions (% of total fuel combustion) of Tanzania in 2001 to that in 2004?
Offer a very short reply. 2.96. What is the ratio of the CO2 emissions (% of total fuel combustion) in Latin America(developing only) in 2001 to that in 2005?
Your answer should be very brief. 1.04. What is the ratio of the CO2 emissions (% of total fuel combustion) of Middle income in 2001 to that in 2005?
Keep it short and to the point. 1.06. What is the ratio of the CO2 emissions (% of total fuel combustion) in Egypt, Arab Rep. in 2001 to that in 2005?
Offer a very short reply. 0.05. What is the ratio of the CO2 emissions (% of total fuel combustion) in Tanzania in 2001 to that in 2005?
Provide a succinct answer. 2.73. What is the ratio of the CO2 emissions (% of total fuel combustion) in Latin America(developing only) in 2001 to that in 2006?
Make the answer very short. 1.05. What is the ratio of the CO2 emissions (% of total fuel combustion) in Middle income in 2001 to that in 2006?
Ensure brevity in your answer.  1.07. What is the ratio of the CO2 emissions (% of total fuel combustion) of Egypt, Arab Rep. in 2001 to that in 2006?
Your answer should be compact. 0.05. What is the ratio of the CO2 emissions (% of total fuel combustion) of Tanzania in 2001 to that in 2006?
Provide a succinct answer. 4.42. What is the ratio of the CO2 emissions (% of total fuel combustion) in Latin America(developing only) in 2002 to that in 2003?
Offer a very short reply. 0.95. What is the ratio of the CO2 emissions (% of total fuel combustion) of Middle income in 2002 to that in 2003?
Your answer should be very brief. 1.01. What is the ratio of the CO2 emissions (% of total fuel combustion) in Egypt, Arab Rep. in 2002 to that in 2003?
Your answer should be very brief. 1.31. What is the ratio of the CO2 emissions (% of total fuel combustion) in Tanzania in 2002 to that in 2003?
Offer a terse response. 1.04. What is the ratio of the CO2 emissions (% of total fuel combustion) of Latin America(developing only) in 2002 to that in 2004?
Your answer should be very brief. 0.96. What is the ratio of the CO2 emissions (% of total fuel combustion) in Middle income in 2002 to that in 2004?
Make the answer very short. 1. What is the ratio of the CO2 emissions (% of total fuel combustion) of Egypt, Arab Rep. in 2002 to that in 2004?
Provide a succinct answer. 0.09. What is the ratio of the CO2 emissions (% of total fuel combustion) in Tanzania in 2002 to that in 2004?
Your answer should be very brief. 1.44. What is the ratio of the CO2 emissions (% of total fuel combustion) in Middle income in 2002 to that in 2005?
Provide a short and direct response. 1.01. What is the ratio of the CO2 emissions (% of total fuel combustion) of Egypt, Arab Rep. in 2002 to that in 2005?
Your answer should be compact. 0.04. What is the ratio of the CO2 emissions (% of total fuel combustion) in Tanzania in 2002 to that in 2005?
Your response must be concise. 1.33. What is the ratio of the CO2 emissions (% of total fuel combustion) in Middle income in 2002 to that in 2006?
Ensure brevity in your answer.  1.03. What is the ratio of the CO2 emissions (% of total fuel combustion) in Egypt, Arab Rep. in 2002 to that in 2006?
Give a very brief answer. 0.05. What is the ratio of the CO2 emissions (% of total fuel combustion) of Tanzania in 2002 to that in 2006?
Provide a short and direct response. 2.15. What is the ratio of the CO2 emissions (% of total fuel combustion) of Latin America(developing only) in 2003 to that in 2004?
Give a very brief answer. 1.01. What is the ratio of the CO2 emissions (% of total fuel combustion) of Egypt, Arab Rep. in 2003 to that in 2004?
Make the answer very short. 0.07. What is the ratio of the CO2 emissions (% of total fuel combustion) in Tanzania in 2003 to that in 2004?
Provide a short and direct response. 1.38. What is the ratio of the CO2 emissions (% of total fuel combustion) in Latin America(developing only) in 2003 to that in 2005?
Keep it short and to the point. 1.04. What is the ratio of the CO2 emissions (% of total fuel combustion) of Middle income in 2003 to that in 2005?
Provide a succinct answer. 1. What is the ratio of the CO2 emissions (% of total fuel combustion) of Egypt, Arab Rep. in 2003 to that in 2005?
Your response must be concise. 0.03. What is the ratio of the CO2 emissions (% of total fuel combustion) in Tanzania in 2003 to that in 2005?
Provide a succinct answer. 1.28. What is the ratio of the CO2 emissions (% of total fuel combustion) of Latin America(developing only) in 2003 to that in 2006?
Make the answer very short. 1.05. What is the ratio of the CO2 emissions (% of total fuel combustion) of Middle income in 2003 to that in 2006?
Keep it short and to the point. 1.02. What is the ratio of the CO2 emissions (% of total fuel combustion) of Egypt, Arab Rep. in 2003 to that in 2006?
Provide a succinct answer. 0.03. What is the ratio of the CO2 emissions (% of total fuel combustion) in Tanzania in 2003 to that in 2006?
Ensure brevity in your answer.  2.06. What is the ratio of the CO2 emissions (% of total fuel combustion) of Latin America(developing only) in 2004 to that in 2005?
Make the answer very short. 1.03. What is the ratio of the CO2 emissions (% of total fuel combustion) in Middle income in 2004 to that in 2005?
Your response must be concise. 1.01. What is the ratio of the CO2 emissions (% of total fuel combustion) of Egypt, Arab Rep. in 2004 to that in 2005?
Keep it short and to the point. 0.47. What is the ratio of the CO2 emissions (% of total fuel combustion) in Tanzania in 2004 to that in 2005?
Offer a terse response. 0.92. What is the ratio of the CO2 emissions (% of total fuel combustion) of Latin America(developing only) in 2004 to that in 2006?
Your answer should be very brief. 1.04. What is the ratio of the CO2 emissions (% of total fuel combustion) of Middle income in 2004 to that in 2006?
Keep it short and to the point. 1.03. What is the ratio of the CO2 emissions (% of total fuel combustion) in Egypt, Arab Rep. in 2004 to that in 2006?
Offer a very short reply. 0.48. What is the ratio of the CO2 emissions (% of total fuel combustion) in Tanzania in 2004 to that in 2006?
Give a very brief answer. 1.49. What is the ratio of the CO2 emissions (% of total fuel combustion) of Latin America(developing only) in 2005 to that in 2006?
Provide a succinct answer. 1.01. What is the ratio of the CO2 emissions (% of total fuel combustion) in Middle income in 2005 to that in 2006?
Your answer should be very brief. 1.01. What is the ratio of the CO2 emissions (% of total fuel combustion) in Egypt, Arab Rep. in 2005 to that in 2006?
Your answer should be very brief. 1.01. What is the ratio of the CO2 emissions (% of total fuel combustion) of Tanzania in 2005 to that in 2006?
Your answer should be very brief. 1.62. What is the difference between the highest and the second highest CO2 emissions (% of total fuel combustion) in Latin America(developing only)?
Offer a very short reply. 0.02. What is the difference between the highest and the second highest CO2 emissions (% of total fuel combustion) in Middle income?
Provide a short and direct response. 0. What is the difference between the highest and the second highest CO2 emissions (% of total fuel combustion) of Egypt, Arab Rep.?
Provide a succinct answer. 0.03. What is the difference between the highest and the second highest CO2 emissions (% of total fuel combustion) of Tanzania?
Offer a terse response. 0.56. What is the difference between the highest and the lowest CO2 emissions (% of total fuel combustion) of Latin America(developing only)?
Make the answer very short. 0.22. What is the difference between the highest and the lowest CO2 emissions (% of total fuel combustion) of Egypt, Arab Rep.?
Offer a terse response. 3.47. What is the difference between the highest and the lowest CO2 emissions (% of total fuel combustion) in Tanzania?
Provide a short and direct response. 2.5. 